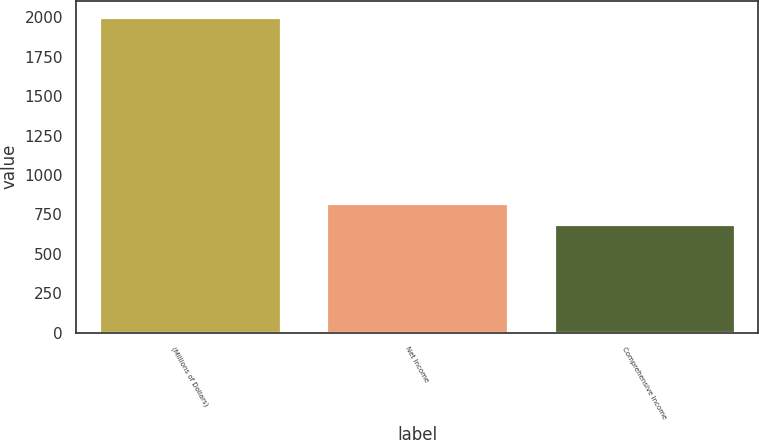Convert chart to OTSL. <chart><loc_0><loc_0><loc_500><loc_500><bar_chart><fcel>(Millions of Dollars)<fcel>Net Income<fcel>Comprehensive Income<nl><fcel>2006<fcel>822.5<fcel>691<nl></chart> 